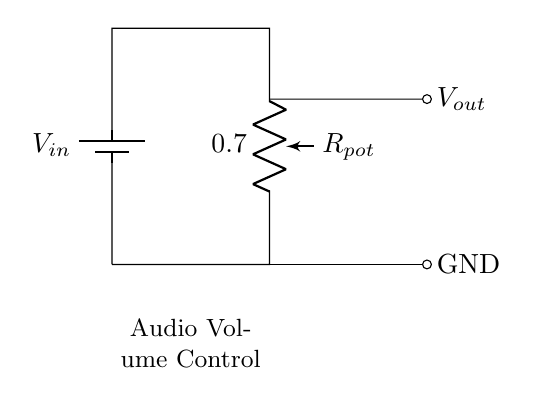What type of circuit is shown? The circuit is a voltage divider. A voltage divider is a simple circuit used to reduce voltage, and this one specifically uses a potentiometer to adjust the output voltage.
Answer: Voltage divider What does the potentiometer do in this circuit? The potentiometer functions as a variable resistor, allowing the user to adjust the output voltage by changing the resistance. This adjustment changes the division of the input voltage across the potentiometer.
Answer: Adjusts output voltage What is the role of Vout in this circuit? Vout represents the output voltage that is taken from the voltage divider. It varies based on the resistance setting of the potentiometer, providing the user control over the audio volume.
Answer: Output voltage What is connected to GND in this circuit? GND is connected to the bottom terminal of the potentiometer, which establishes a reference point for the circuit and completes the circuit path.
Answer: The bottom terminal of the potentiometer How does the input voltage affect the output voltage? The output voltage depends on the ratio of the resistances in the potentiometer. The higher the resistance selected, the lower the output voltage, effectively lowering the audio volume. Thus, Vout decreases as the total resistance of the pot increases.
Answer: It decreases What happens if the potentiometer is adjusted to maximum resistance? If the potentiometer is set to maximum resistance, the output voltage Vout will be at its minimum, essentially resulting in no audio output, as most of the input voltage will drop across the potentiometer.
Answer: Vout is minimum What is Vout when the potentiometer is at its midpoint? At midpoint, Vout will be approximately half of Vin, based on the principle that the voltage divides evenly across the half-resistances in a linear potentiometer. This means half the input voltage is applied to Vout when adjusted to the center.
Answer: Half of Vin 